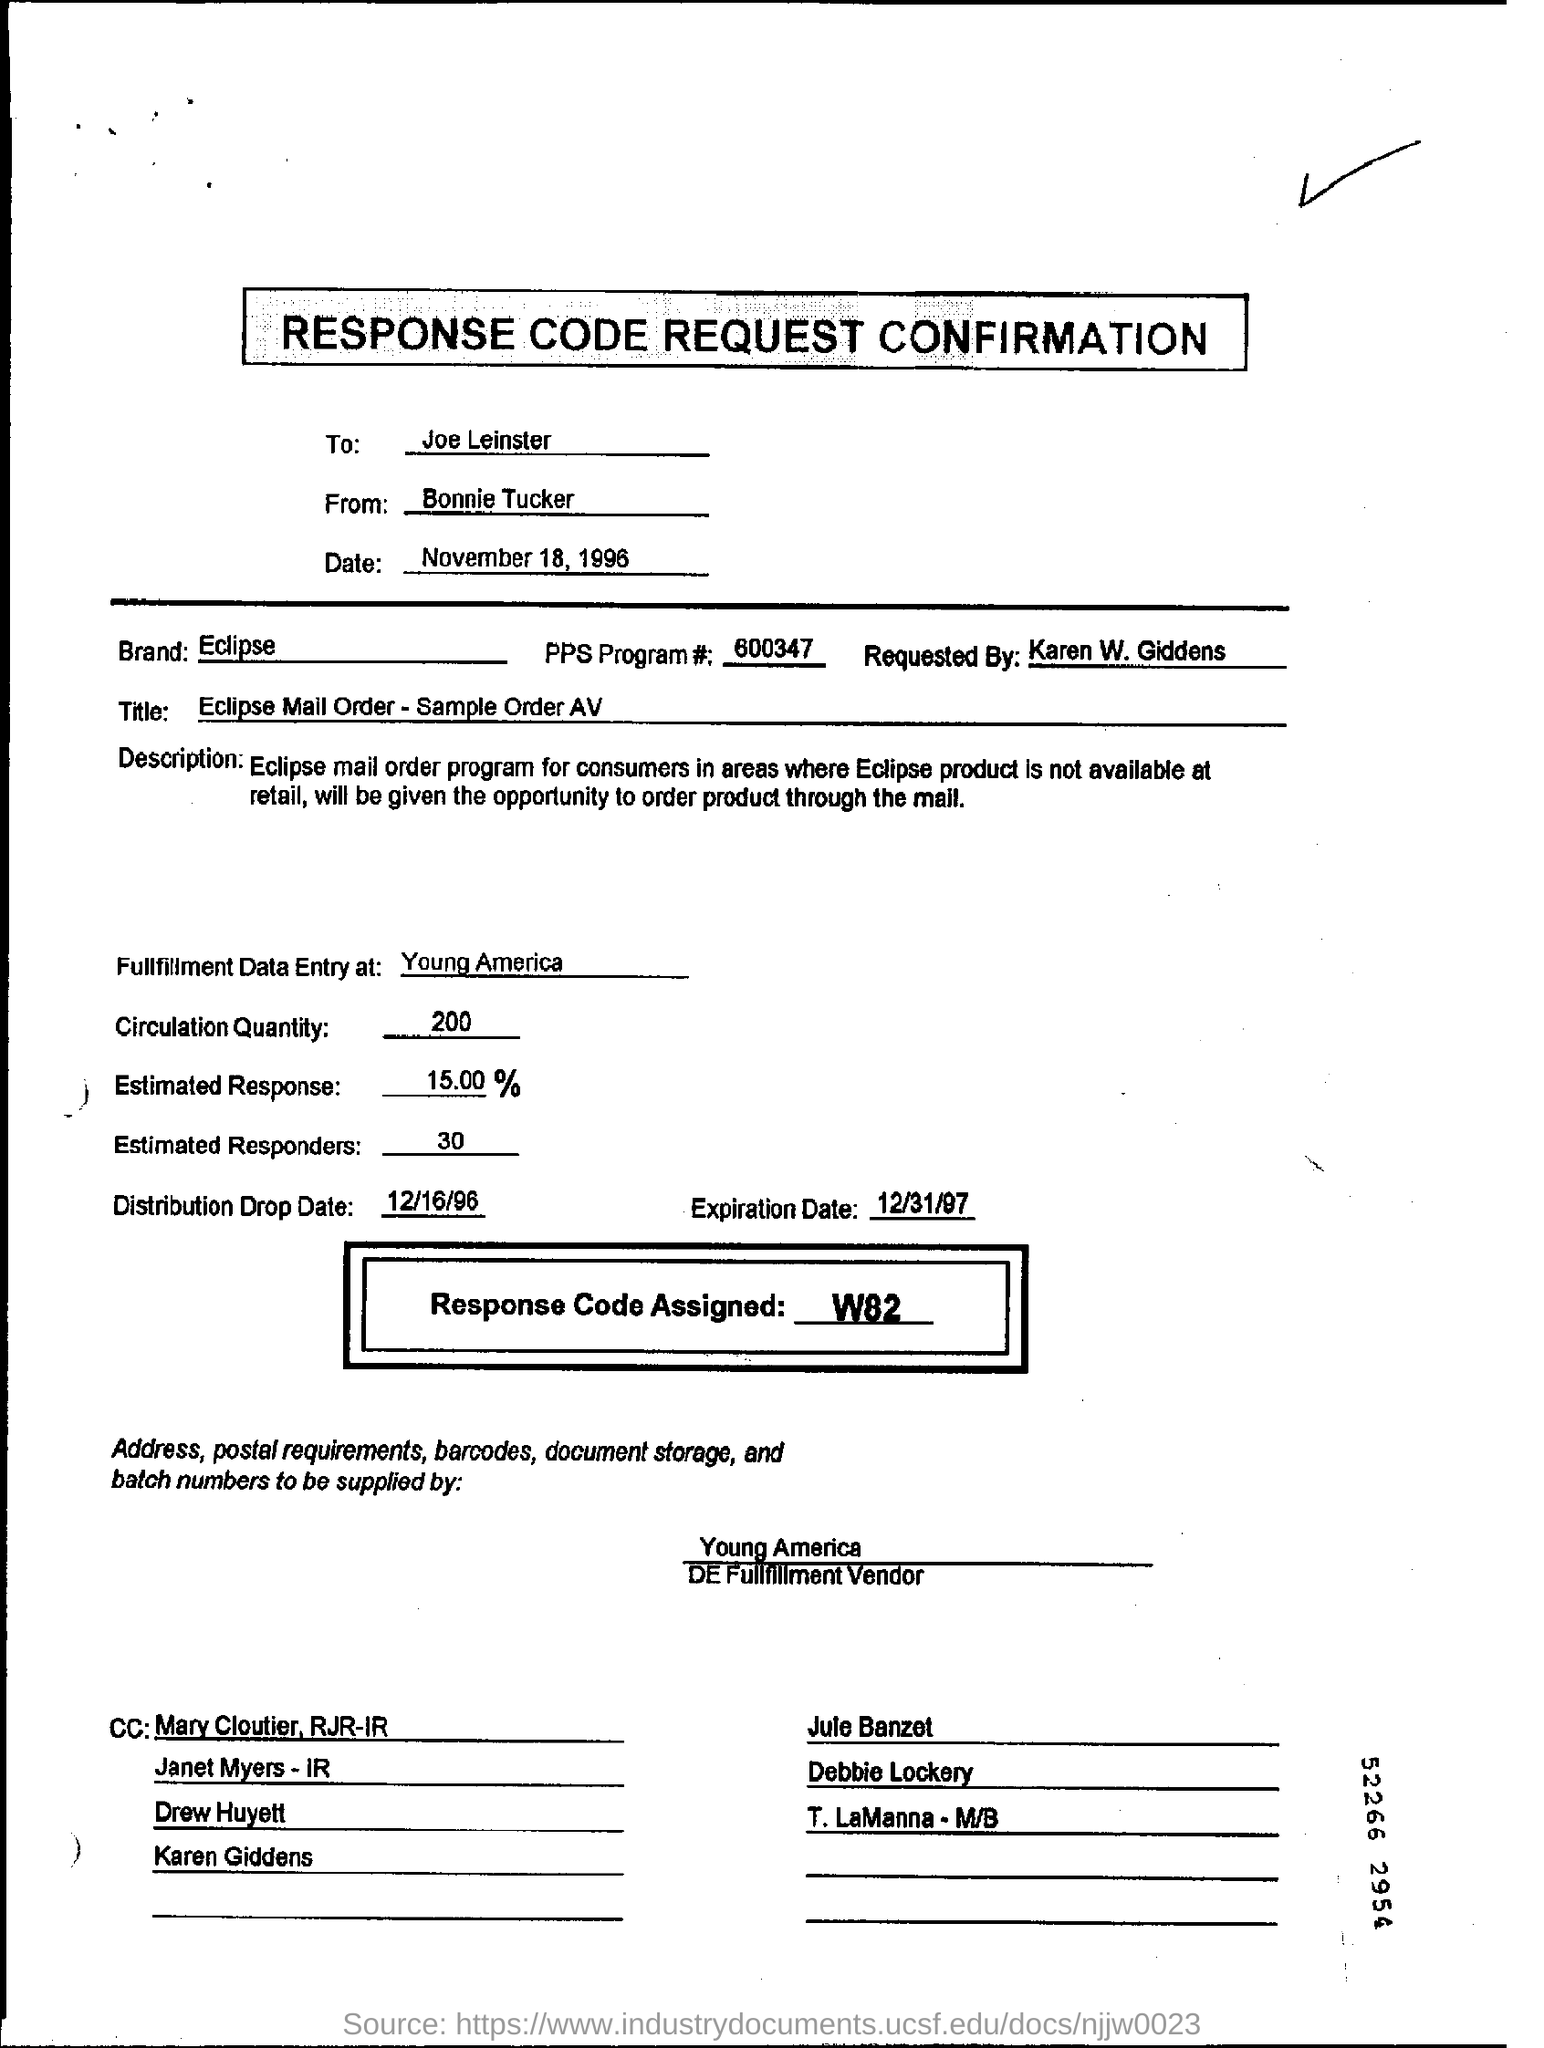Mention a couple of crucial points in this snapshot. The first CC is addressed to Mary Cloutier of RJR-IR. The circulation quantity is approximately 200. The confirmation is addressed to Joe Leinster. What is the assigned response code? W82... 